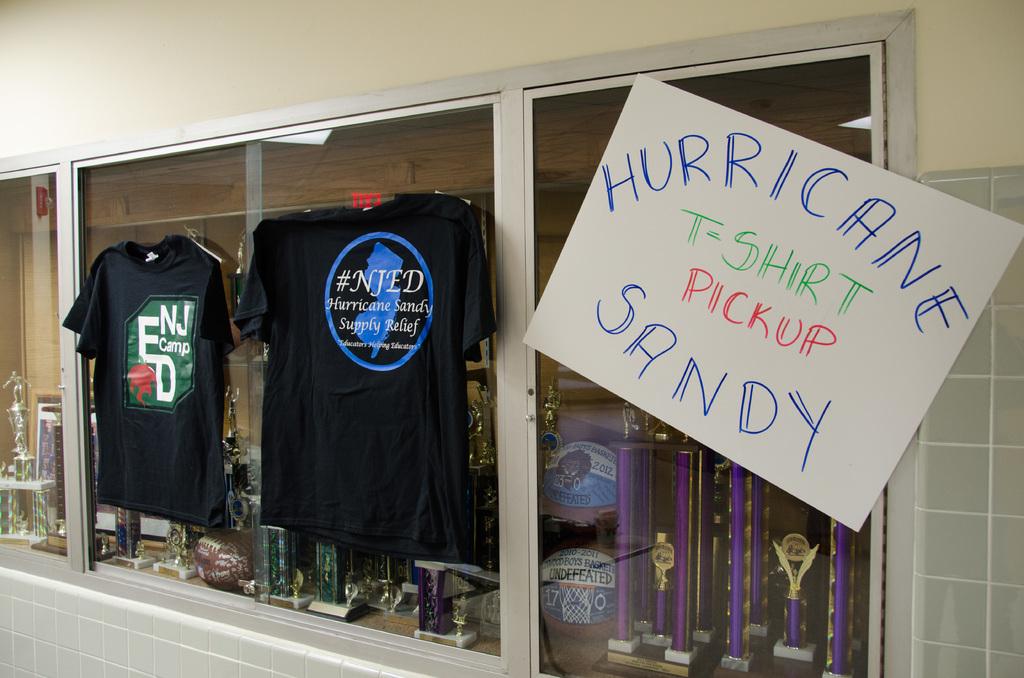What are the shirts being sold for?
Your response must be concise. Hurricane sandy. What are the shirts supporting?
Offer a terse response. Hurricane sandy. 